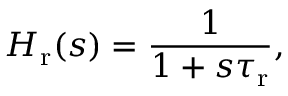<formula> <loc_0><loc_0><loc_500><loc_500>H _ { r } ( s ) = \frac { 1 } { 1 + s \tau _ { r } } ,</formula> 